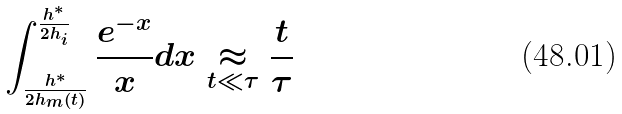<formula> <loc_0><loc_0><loc_500><loc_500>\int _ { \frac { h ^ { * } } { 2 h _ { m } ( t ) } } ^ { \frac { h ^ { * } } { 2 h _ { i } } } \frac { e ^ { - x } } { x } d x \underset { t \ll \tau } { \approx } \frac { t } { \tau }</formula> 